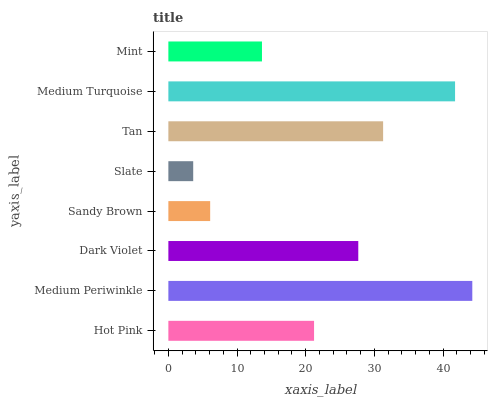Is Slate the minimum?
Answer yes or no. Yes. Is Medium Periwinkle the maximum?
Answer yes or no. Yes. Is Dark Violet the minimum?
Answer yes or no. No. Is Dark Violet the maximum?
Answer yes or no. No. Is Medium Periwinkle greater than Dark Violet?
Answer yes or no. Yes. Is Dark Violet less than Medium Periwinkle?
Answer yes or no. Yes. Is Dark Violet greater than Medium Periwinkle?
Answer yes or no. No. Is Medium Periwinkle less than Dark Violet?
Answer yes or no. No. Is Dark Violet the high median?
Answer yes or no. Yes. Is Hot Pink the low median?
Answer yes or no. Yes. Is Sandy Brown the high median?
Answer yes or no. No. Is Dark Violet the low median?
Answer yes or no. No. 